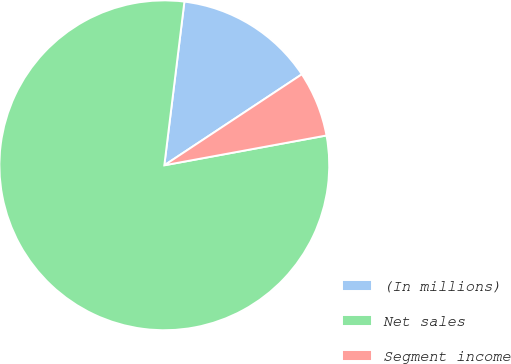Convert chart to OTSL. <chart><loc_0><loc_0><loc_500><loc_500><pie_chart><fcel>(In millions)<fcel>Net sales<fcel>Segment income<nl><fcel>13.75%<fcel>79.83%<fcel>6.41%<nl></chart> 